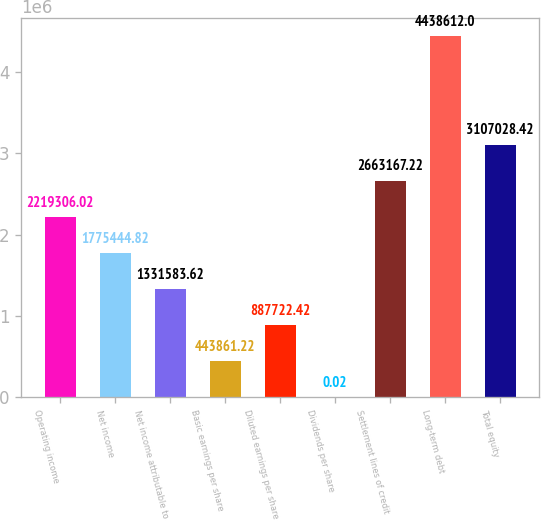<chart> <loc_0><loc_0><loc_500><loc_500><bar_chart><fcel>Operating income<fcel>Net income<fcel>Net income attributable to<fcel>Basic earnings per share<fcel>Diluted earnings per share<fcel>Dividends per share<fcel>Settlement lines of credit<fcel>Long-term debt<fcel>Total equity<nl><fcel>2.21931e+06<fcel>1.77544e+06<fcel>1.33158e+06<fcel>443861<fcel>887722<fcel>0.02<fcel>2.66317e+06<fcel>4.43861e+06<fcel>3.10703e+06<nl></chart> 